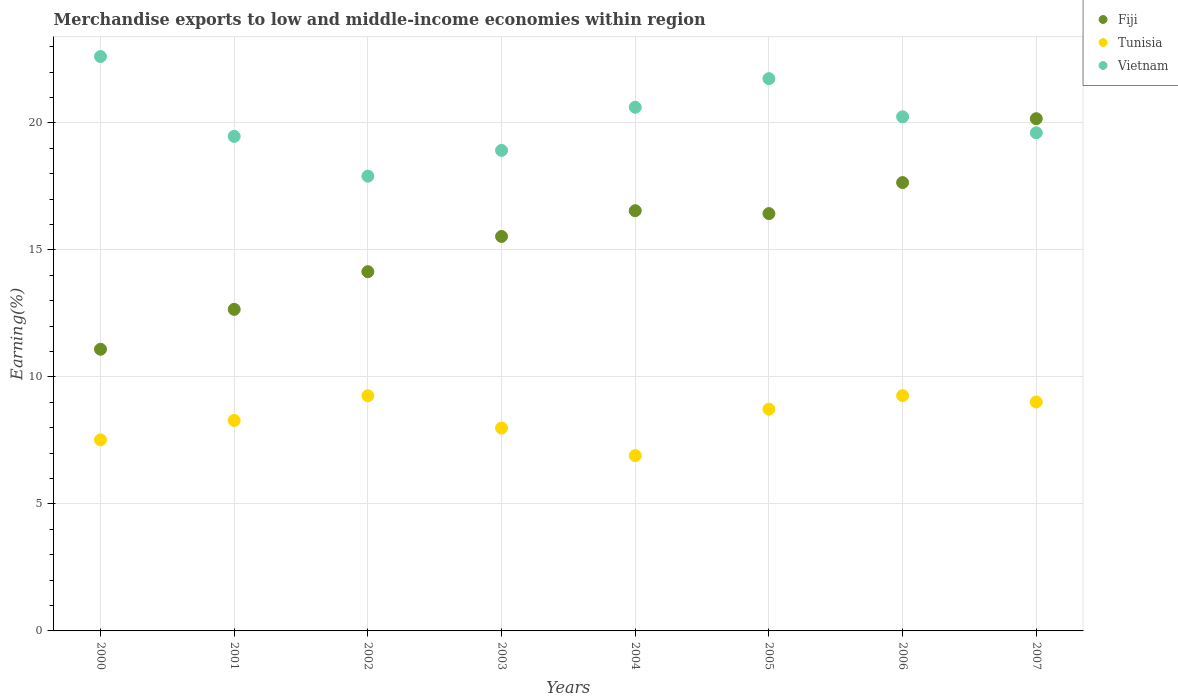Is the number of dotlines equal to the number of legend labels?
Provide a succinct answer. Yes. What is the percentage of amount earned from merchandise exports in Fiji in 2003?
Keep it short and to the point. 15.53. Across all years, what is the maximum percentage of amount earned from merchandise exports in Fiji?
Your answer should be very brief. 20.16. Across all years, what is the minimum percentage of amount earned from merchandise exports in Fiji?
Provide a short and direct response. 11.09. In which year was the percentage of amount earned from merchandise exports in Fiji maximum?
Keep it short and to the point. 2007. What is the total percentage of amount earned from merchandise exports in Fiji in the graph?
Your response must be concise. 124.2. What is the difference between the percentage of amount earned from merchandise exports in Fiji in 2001 and that in 2007?
Your answer should be compact. -7.51. What is the difference between the percentage of amount earned from merchandise exports in Tunisia in 2001 and the percentage of amount earned from merchandise exports in Fiji in 2005?
Your answer should be very brief. -8.14. What is the average percentage of amount earned from merchandise exports in Vietnam per year?
Offer a very short reply. 20.14. In the year 2006, what is the difference between the percentage of amount earned from merchandise exports in Vietnam and percentage of amount earned from merchandise exports in Fiji?
Offer a very short reply. 2.59. What is the ratio of the percentage of amount earned from merchandise exports in Tunisia in 2002 to that in 2004?
Give a very brief answer. 1.34. Is the difference between the percentage of amount earned from merchandise exports in Vietnam in 2003 and 2005 greater than the difference between the percentage of amount earned from merchandise exports in Fiji in 2003 and 2005?
Keep it short and to the point. No. What is the difference between the highest and the second highest percentage of amount earned from merchandise exports in Tunisia?
Offer a very short reply. 0.01. What is the difference between the highest and the lowest percentage of amount earned from merchandise exports in Vietnam?
Give a very brief answer. 4.71. In how many years, is the percentage of amount earned from merchandise exports in Tunisia greater than the average percentage of amount earned from merchandise exports in Tunisia taken over all years?
Ensure brevity in your answer.  4. Is the sum of the percentage of amount earned from merchandise exports in Vietnam in 2000 and 2004 greater than the maximum percentage of amount earned from merchandise exports in Fiji across all years?
Provide a short and direct response. Yes. Is it the case that in every year, the sum of the percentage of amount earned from merchandise exports in Tunisia and percentage of amount earned from merchandise exports in Fiji  is greater than the percentage of amount earned from merchandise exports in Vietnam?
Keep it short and to the point. No. Does the percentage of amount earned from merchandise exports in Fiji monotonically increase over the years?
Give a very brief answer. No. Is the percentage of amount earned from merchandise exports in Fiji strictly greater than the percentage of amount earned from merchandise exports in Tunisia over the years?
Offer a terse response. Yes. Does the graph contain grids?
Make the answer very short. Yes. Where does the legend appear in the graph?
Give a very brief answer. Top right. What is the title of the graph?
Your answer should be compact. Merchandise exports to low and middle-income economies within region. Does "El Salvador" appear as one of the legend labels in the graph?
Provide a short and direct response. No. What is the label or title of the X-axis?
Your response must be concise. Years. What is the label or title of the Y-axis?
Offer a very short reply. Earning(%). What is the Earning(%) in Fiji in 2000?
Ensure brevity in your answer.  11.09. What is the Earning(%) in Tunisia in 2000?
Your answer should be compact. 7.52. What is the Earning(%) of Vietnam in 2000?
Give a very brief answer. 22.61. What is the Earning(%) of Fiji in 2001?
Provide a succinct answer. 12.66. What is the Earning(%) in Tunisia in 2001?
Your answer should be compact. 8.28. What is the Earning(%) in Vietnam in 2001?
Ensure brevity in your answer.  19.47. What is the Earning(%) in Fiji in 2002?
Keep it short and to the point. 14.14. What is the Earning(%) of Tunisia in 2002?
Your answer should be very brief. 9.26. What is the Earning(%) of Vietnam in 2002?
Your response must be concise. 17.9. What is the Earning(%) of Fiji in 2003?
Your answer should be very brief. 15.53. What is the Earning(%) of Tunisia in 2003?
Offer a terse response. 7.98. What is the Earning(%) of Vietnam in 2003?
Offer a very short reply. 18.92. What is the Earning(%) of Fiji in 2004?
Your answer should be compact. 16.54. What is the Earning(%) of Tunisia in 2004?
Ensure brevity in your answer.  6.9. What is the Earning(%) of Vietnam in 2004?
Ensure brevity in your answer.  20.61. What is the Earning(%) of Fiji in 2005?
Your answer should be very brief. 16.43. What is the Earning(%) of Tunisia in 2005?
Provide a succinct answer. 8.73. What is the Earning(%) in Vietnam in 2005?
Provide a succinct answer. 21.74. What is the Earning(%) of Fiji in 2006?
Your response must be concise. 17.65. What is the Earning(%) in Tunisia in 2006?
Make the answer very short. 9.26. What is the Earning(%) in Vietnam in 2006?
Make the answer very short. 20.24. What is the Earning(%) of Fiji in 2007?
Offer a terse response. 20.16. What is the Earning(%) of Tunisia in 2007?
Offer a terse response. 9.01. What is the Earning(%) in Vietnam in 2007?
Offer a very short reply. 19.61. Across all years, what is the maximum Earning(%) of Fiji?
Provide a short and direct response. 20.16. Across all years, what is the maximum Earning(%) of Tunisia?
Make the answer very short. 9.26. Across all years, what is the maximum Earning(%) of Vietnam?
Provide a short and direct response. 22.61. Across all years, what is the minimum Earning(%) of Fiji?
Give a very brief answer. 11.09. Across all years, what is the minimum Earning(%) of Tunisia?
Provide a succinct answer. 6.9. Across all years, what is the minimum Earning(%) of Vietnam?
Provide a succinct answer. 17.9. What is the total Earning(%) in Fiji in the graph?
Your response must be concise. 124.2. What is the total Earning(%) of Tunisia in the graph?
Make the answer very short. 66.95. What is the total Earning(%) in Vietnam in the graph?
Offer a terse response. 161.09. What is the difference between the Earning(%) in Fiji in 2000 and that in 2001?
Provide a short and direct response. -1.57. What is the difference between the Earning(%) of Tunisia in 2000 and that in 2001?
Your answer should be compact. -0.76. What is the difference between the Earning(%) in Vietnam in 2000 and that in 2001?
Make the answer very short. 3.14. What is the difference between the Earning(%) of Fiji in 2000 and that in 2002?
Make the answer very short. -3.05. What is the difference between the Earning(%) in Tunisia in 2000 and that in 2002?
Your answer should be very brief. -1.73. What is the difference between the Earning(%) in Vietnam in 2000 and that in 2002?
Give a very brief answer. 4.71. What is the difference between the Earning(%) of Fiji in 2000 and that in 2003?
Make the answer very short. -4.44. What is the difference between the Earning(%) in Tunisia in 2000 and that in 2003?
Your response must be concise. -0.46. What is the difference between the Earning(%) of Vietnam in 2000 and that in 2003?
Ensure brevity in your answer.  3.7. What is the difference between the Earning(%) of Fiji in 2000 and that in 2004?
Your response must be concise. -5.45. What is the difference between the Earning(%) in Tunisia in 2000 and that in 2004?
Your response must be concise. 0.62. What is the difference between the Earning(%) of Vietnam in 2000 and that in 2004?
Your answer should be compact. 2. What is the difference between the Earning(%) in Fiji in 2000 and that in 2005?
Offer a very short reply. -5.34. What is the difference between the Earning(%) of Tunisia in 2000 and that in 2005?
Keep it short and to the point. -1.21. What is the difference between the Earning(%) in Vietnam in 2000 and that in 2005?
Your answer should be compact. 0.87. What is the difference between the Earning(%) of Fiji in 2000 and that in 2006?
Provide a succinct answer. -6.56. What is the difference between the Earning(%) in Tunisia in 2000 and that in 2006?
Give a very brief answer. -1.74. What is the difference between the Earning(%) of Vietnam in 2000 and that in 2006?
Keep it short and to the point. 2.37. What is the difference between the Earning(%) in Fiji in 2000 and that in 2007?
Your answer should be compact. -9.08. What is the difference between the Earning(%) in Tunisia in 2000 and that in 2007?
Make the answer very short. -1.49. What is the difference between the Earning(%) in Vietnam in 2000 and that in 2007?
Ensure brevity in your answer.  3. What is the difference between the Earning(%) in Fiji in 2001 and that in 2002?
Provide a short and direct response. -1.48. What is the difference between the Earning(%) of Tunisia in 2001 and that in 2002?
Provide a short and direct response. -0.97. What is the difference between the Earning(%) of Vietnam in 2001 and that in 2002?
Your answer should be very brief. 1.57. What is the difference between the Earning(%) in Fiji in 2001 and that in 2003?
Keep it short and to the point. -2.87. What is the difference between the Earning(%) in Tunisia in 2001 and that in 2003?
Your response must be concise. 0.3. What is the difference between the Earning(%) of Vietnam in 2001 and that in 2003?
Provide a short and direct response. 0.55. What is the difference between the Earning(%) of Fiji in 2001 and that in 2004?
Your response must be concise. -3.88. What is the difference between the Earning(%) of Tunisia in 2001 and that in 2004?
Offer a very short reply. 1.38. What is the difference between the Earning(%) in Vietnam in 2001 and that in 2004?
Give a very brief answer. -1.15. What is the difference between the Earning(%) of Fiji in 2001 and that in 2005?
Your answer should be compact. -3.77. What is the difference between the Earning(%) in Tunisia in 2001 and that in 2005?
Your answer should be compact. -0.44. What is the difference between the Earning(%) of Vietnam in 2001 and that in 2005?
Give a very brief answer. -2.27. What is the difference between the Earning(%) of Fiji in 2001 and that in 2006?
Give a very brief answer. -4.99. What is the difference between the Earning(%) in Tunisia in 2001 and that in 2006?
Provide a short and direct response. -0.98. What is the difference between the Earning(%) of Vietnam in 2001 and that in 2006?
Your response must be concise. -0.77. What is the difference between the Earning(%) in Fiji in 2001 and that in 2007?
Keep it short and to the point. -7.51. What is the difference between the Earning(%) in Tunisia in 2001 and that in 2007?
Provide a short and direct response. -0.73. What is the difference between the Earning(%) in Vietnam in 2001 and that in 2007?
Offer a very short reply. -0.14. What is the difference between the Earning(%) in Fiji in 2002 and that in 2003?
Ensure brevity in your answer.  -1.39. What is the difference between the Earning(%) in Tunisia in 2002 and that in 2003?
Your answer should be very brief. 1.27. What is the difference between the Earning(%) of Vietnam in 2002 and that in 2003?
Your answer should be compact. -1.01. What is the difference between the Earning(%) in Fiji in 2002 and that in 2004?
Offer a very short reply. -2.4. What is the difference between the Earning(%) in Tunisia in 2002 and that in 2004?
Offer a very short reply. 2.36. What is the difference between the Earning(%) in Vietnam in 2002 and that in 2004?
Offer a very short reply. -2.71. What is the difference between the Earning(%) in Fiji in 2002 and that in 2005?
Offer a very short reply. -2.29. What is the difference between the Earning(%) of Tunisia in 2002 and that in 2005?
Give a very brief answer. 0.53. What is the difference between the Earning(%) of Vietnam in 2002 and that in 2005?
Offer a very short reply. -3.84. What is the difference between the Earning(%) of Fiji in 2002 and that in 2006?
Provide a short and direct response. -3.51. What is the difference between the Earning(%) in Tunisia in 2002 and that in 2006?
Keep it short and to the point. -0.01. What is the difference between the Earning(%) in Vietnam in 2002 and that in 2006?
Your answer should be compact. -2.33. What is the difference between the Earning(%) of Fiji in 2002 and that in 2007?
Provide a short and direct response. -6.02. What is the difference between the Earning(%) in Tunisia in 2002 and that in 2007?
Ensure brevity in your answer.  0.24. What is the difference between the Earning(%) in Vietnam in 2002 and that in 2007?
Your answer should be very brief. -1.71. What is the difference between the Earning(%) in Fiji in 2003 and that in 2004?
Your answer should be very brief. -1.01. What is the difference between the Earning(%) in Tunisia in 2003 and that in 2004?
Offer a very short reply. 1.08. What is the difference between the Earning(%) in Vietnam in 2003 and that in 2004?
Make the answer very short. -1.7. What is the difference between the Earning(%) of Fiji in 2003 and that in 2005?
Provide a succinct answer. -0.9. What is the difference between the Earning(%) of Tunisia in 2003 and that in 2005?
Provide a succinct answer. -0.74. What is the difference between the Earning(%) in Vietnam in 2003 and that in 2005?
Provide a short and direct response. -2.82. What is the difference between the Earning(%) of Fiji in 2003 and that in 2006?
Your answer should be very brief. -2.12. What is the difference between the Earning(%) of Tunisia in 2003 and that in 2006?
Provide a succinct answer. -1.28. What is the difference between the Earning(%) in Vietnam in 2003 and that in 2006?
Keep it short and to the point. -1.32. What is the difference between the Earning(%) of Fiji in 2003 and that in 2007?
Ensure brevity in your answer.  -4.64. What is the difference between the Earning(%) of Tunisia in 2003 and that in 2007?
Offer a terse response. -1.03. What is the difference between the Earning(%) in Vietnam in 2003 and that in 2007?
Make the answer very short. -0.69. What is the difference between the Earning(%) of Fiji in 2004 and that in 2005?
Make the answer very short. 0.11. What is the difference between the Earning(%) in Tunisia in 2004 and that in 2005?
Make the answer very short. -1.83. What is the difference between the Earning(%) of Vietnam in 2004 and that in 2005?
Offer a very short reply. -1.13. What is the difference between the Earning(%) of Fiji in 2004 and that in 2006?
Your answer should be very brief. -1.11. What is the difference between the Earning(%) of Tunisia in 2004 and that in 2006?
Provide a succinct answer. -2.36. What is the difference between the Earning(%) of Vietnam in 2004 and that in 2006?
Keep it short and to the point. 0.38. What is the difference between the Earning(%) in Fiji in 2004 and that in 2007?
Your response must be concise. -3.62. What is the difference between the Earning(%) of Tunisia in 2004 and that in 2007?
Your answer should be very brief. -2.11. What is the difference between the Earning(%) of Fiji in 2005 and that in 2006?
Make the answer very short. -1.22. What is the difference between the Earning(%) in Tunisia in 2005 and that in 2006?
Your answer should be very brief. -0.54. What is the difference between the Earning(%) in Vietnam in 2005 and that in 2006?
Offer a terse response. 1.5. What is the difference between the Earning(%) of Fiji in 2005 and that in 2007?
Make the answer very short. -3.74. What is the difference between the Earning(%) of Tunisia in 2005 and that in 2007?
Ensure brevity in your answer.  -0.29. What is the difference between the Earning(%) in Vietnam in 2005 and that in 2007?
Give a very brief answer. 2.13. What is the difference between the Earning(%) in Fiji in 2006 and that in 2007?
Make the answer very short. -2.52. What is the difference between the Earning(%) of Tunisia in 2006 and that in 2007?
Your answer should be very brief. 0.25. What is the difference between the Earning(%) in Vietnam in 2006 and that in 2007?
Your answer should be compact. 0.63. What is the difference between the Earning(%) of Fiji in 2000 and the Earning(%) of Tunisia in 2001?
Your answer should be very brief. 2.8. What is the difference between the Earning(%) in Fiji in 2000 and the Earning(%) in Vietnam in 2001?
Ensure brevity in your answer.  -8.38. What is the difference between the Earning(%) of Tunisia in 2000 and the Earning(%) of Vietnam in 2001?
Your answer should be compact. -11.95. What is the difference between the Earning(%) in Fiji in 2000 and the Earning(%) in Tunisia in 2002?
Offer a terse response. 1.83. What is the difference between the Earning(%) in Fiji in 2000 and the Earning(%) in Vietnam in 2002?
Provide a succinct answer. -6.81. What is the difference between the Earning(%) of Tunisia in 2000 and the Earning(%) of Vietnam in 2002?
Your answer should be very brief. -10.38. What is the difference between the Earning(%) in Fiji in 2000 and the Earning(%) in Tunisia in 2003?
Provide a succinct answer. 3.1. What is the difference between the Earning(%) in Fiji in 2000 and the Earning(%) in Vietnam in 2003?
Give a very brief answer. -7.83. What is the difference between the Earning(%) of Tunisia in 2000 and the Earning(%) of Vietnam in 2003?
Give a very brief answer. -11.39. What is the difference between the Earning(%) in Fiji in 2000 and the Earning(%) in Tunisia in 2004?
Ensure brevity in your answer.  4.19. What is the difference between the Earning(%) in Fiji in 2000 and the Earning(%) in Vietnam in 2004?
Ensure brevity in your answer.  -9.53. What is the difference between the Earning(%) in Tunisia in 2000 and the Earning(%) in Vietnam in 2004?
Your response must be concise. -13.09. What is the difference between the Earning(%) of Fiji in 2000 and the Earning(%) of Tunisia in 2005?
Your response must be concise. 2.36. What is the difference between the Earning(%) of Fiji in 2000 and the Earning(%) of Vietnam in 2005?
Provide a short and direct response. -10.65. What is the difference between the Earning(%) of Tunisia in 2000 and the Earning(%) of Vietnam in 2005?
Provide a short and direct response. -14.22. What is the difference between the Earning(%) of Fiji in 2000 and the Earning(%) of Tunisia in 2006?
Ensure brevity in your answer.  1.82. What is the difference between the Earning(%) of Fiji in 2000 and the Earning(%) of Vietnam in 2006?
Your answer should be very brief. -9.15. What is the difference between the Earning(%) in Tunisia in 2000 and the Earning(%) in Vietnam in 2006?
Your answer should be compact. -12.72. What is the difference between the Earning(%) of Fiji in 2000 and the Earning(%) of Tunisia in 2007?
Ensure brevity in your answer.  2.07. What is the difference between the Earning(%) of Fiji in 2000 and the Earning(%) of Vietnam in 2007?
Your response must be concise. -8.52. What is the difference between the Earning(%) in Tunisia in 2000 and the Earning(%) in Vietnam in 2007?
Your answer should be compact. -12.09. What is the difference between the Earning(%) of Fiji in 2001 and the Earning(%) of Tunisia in 2002?
Offer a terse response. 3.4. What is the difference between the Earning(%) in Fiji in 2001 and the Earning(%) in Vietnam in 2002?
Offer a very short reply. -5.24. What is the difference between the Earning(%) in Tunisia in 2001 and the Earning(%) in Vietnam in 2002?
Offer a terse response. -9.62. What is the difference between the Earning(%) of Fiji in 2001 and the Earning(%) of Tunisia in 2003?
Offer a very short reply. 4.67. What is the difference between the Earning(%) of Fiji in 2001 and the Earning(%) of Vietnam in 2003?
Offer a very short reply. -6.26. What is the difference between the Earning(%) in Tunisia in 2001 and the Earning(%) in Vietnam in 2003?
Make the answer very short. -10.63. What is the difference between the Earning(%) of Fiji in 2001 and the Earning(%) of Tunisia in 2004?
Give a very brief answer. 5.76. What is the difference between the Earning(%) in Fiji in 2001 and the Earning(%) in Vietnam in 2004?
Give a very brief answer. -7.96. What is the difference between the Earning(%) in Tunisia in 2001 and the Earning(%) in Vietnam in 2004?
Give a very brief answer. -12.33. What is the difference between the Earning(%) of Fiji in 2001 and the Earning(%) of Tunisia in 2005?
Make the answer very short. 3.93. What is the difference between the Earning(%) of Fiji in 2001 and the Earning(%) of Vietnam in 2005?
Your response must be concise. -9.08. What is the difference between the Earning(%) of Tunisia in 2001 and the Earning(%) of Vietnam in 2005?
Make the answer very short. -13.46. What is the difference between the Earning(%) of Fiji in 2001 and the Earning(%) of Tunisia in 2006?
Make the answer very short. 3.39. What is the difference between the Earning(%) of Fiji in 2001 and the Earning(%) of Vietnam in 2006?
Provide a short and direct response. -7.58. What is the difference between the Earning(%) of Tunisia in 2001 and the Earning(%) of Vietnam in 2006?
Keep it short and to the point. -11.95. What is the difference between the Earning(%) of Fiji in 2001 and the Earning(%) of Tunisia in 2007?
Your answer should be very brief. 3.65. What is the difference between the Earning(%) in Fiji in 2001 and the Earning(%) in Vietnam in 2007?
Provide a short and direct response. -6.95. What is the difference between the Earning(%) in Tunisia in 2001 and the Earning(%) in Vietnam in 2007?
Give a very brief answer. -11.32. What is the difference between the Earning(%) of Fiji in 2002 and the Earning(%) of Tunisia in 2003?
Offer a terse response. 6.16. What is the difference between the Earning(%) in Fiji in 2002 and the Earning(%) in Vietnam in 2003?
Make the answer very short. -4.77. What is the difference between the Earning(%) in Tunisia in 2002 and the Earning(%) in Vietnam in 2003?
Keep it short and to the point. -9.66. What is the difference between the Earning(%) of Fiji in 2002 and the Earning(%) of Tunisia in 2004?
Your answer should be compact. 7.24. What is the difference between the Earning(%) of Fiji in 2002 and the Earning(%) of Vietnam in 2004?
Ensure brevity in your answer.  -6.47. What is the difference between the Earning(%) of Tunisia in 2002 and the Earning(%) of Vietnam in 2004?
Your response must be concise. -11.36. What is the difference between the Earning(%) in Fiji in 2002 and the Earning(%) in Tunisia in 2005?
Your answer should be very brief. 5.41. What is the difference between the Earning(%) in Fiji in 2002 and the Earning(%) in Vietnam in 2005?
Provide a succinct answer. -7.6. What is the difference between the Earning(%) in Tunisia in 2002 and the Earning(%) in Vietnam in 2005?
Your response must be concise. -12.48. What is the difference between the Earning(%) of Fiji in 2002 and the Earning(%) of Tunisia in 2006?
Provide a succinct answer. 4.88. What is the difference between the Earning(%) in Fiji in 2002 and the Earning(%) in Vietnam in 2006?
Your response must be concise. -6.1. What is the difference between the Earning(%) in Tunisia in 2002 and the Earning(%) in Vietnam in 2006?
Your response must be concise. -10.98. What is the difference between the Earning(%) of Fiji in 2002 and the Earning(%) of Tunisia in 2007?
Your answer should be compact. 5.13. What is the difference between the Earning(%) in Fiji in 2002 and the Earning(%) in Vietnam in 2007?
Provide a succinct answer. -5.47. What is the difference between the Earning(%) of Tunisia in 2002 and the Earning(%) of Vietnam in 2007?
Ensure brevity in your answer.  -10.35. What is the difference between the Earning(%) of Fiji in 2003 and the Earning(%) of Tunisia in 2004?
Your answer should be compact. 8.63. What is the difference between the Earning(%) of Fiji in 2003 and the Earning(%) of Vietnam in 2004?
Give a very brief answer. -5.09. What is the difference between the Earning(%) in Tunisia in 2003 and the Earning(%) in Vietnam in 2004?
Give a very brief answer. -12.63. What is the difference between the Earning(%) in Fiji in 2003 and the Earning(%) in Tunisia in 2005?
Provide a short and direct response. 6.8. What is the difference between the Earning(%) in Fiji in 2003 and the Earning(%) in Vietnam in 2005?
Your response must be concise. -6.21. What is the difference between the Earning(%) in Tunisia in 2003 and the Earning(%) in Vietnam in 2005?
Offer a very short reply. -13.76. What is the difference between the Earning(%) in Fiji in 2003 and the Earning(%) in Tunisia in 2006?
Your answer should be very brief. 6.26. What is the difference between the Earning(%) of Fiji in 2003 and the Earning(%) of Vietnam in 2006?
Ensure brevity in your answer.  -4.71. What is the difference between the Earning(%) in Tunisia in 2003 and the Earning(%) in Vietnam in 2006?
Offer a very short reply. -12.25. What is the difference between the Earning(%) in Fiji in 2003 and the Earning(%) in Tunisia in 2007?
Your answer should be very brief. 6.52. What is the difference between the Earning(%) of Fiji in 2003 and the Earning(%) of Vietnam in 2007?
Ensure brevity in your answer.  -4.08. What is the difference between the Earning(%) of Tunisia in 2003 and the Earning(%) of Vietnam in 2007?
Offer a very short reply. -11.62. What is the difference between the Earning(%) of Fiji in 2004 and the Earning(%) of Tunisia in 2005?
Give a very brief answer. 7.81. What is the difference between the Earning(%) of Fiji in 2004 and the Earning(%) of Vietnam in 2005?
Ensure brevity in your answer.  -5.2. What is the difference between the Earning(%) in Tunisia in 2004 and the Earning(%) in Vietnam in 2005?
Give a very brief answer. -14.84. What is the difference between the Earning(%) in Fiji in 2004 and the Earning(%) in Tunisia in 2006?
Offer a very short reply. 7.28. What is the difference between the Earning(%) of Fiji in 2004 and the Earning(%) of Vietnam in 2006?
Offer a very short reply. -3.7. What is the difference between the Earning(%) of Tunisia in 2004 and the Earning(%) of Vietnam in 2006?
Offer a very short reply. -13.34. What is the difference between the Earning(%) in Fiji in 2004 and the Earning(%) in Tunisia in 2007?
Provide a short and direct response. 7.53. What is the difference between the Earning(%) in Fiji in 2004 and the Earning(%) in Vietnam in 2007?
Keep it short and to the point. -3.07. What is the difference between the Earning(%) in Tunisia in 2004 and the Earning(%) in Vietnam in 2007?
Provide a succinct answer. -12.71. What is the difference between the Earning(%) of Fiji in 2005 and the Earning(%) of Tunisia in 2006?
Your answer should be very brief. 7.16. What is the difference between the Earning(%) in Fiji in 2005 and the Earning(%) in Vietnam in 2006?
Offer a terse response. -3.81. What is the difference between the Earning(%) in Tunisia in 2005 and the Earning(%) in Vietnam in 2006?
Provide a short and direct response. -11.51. What is the difference between the Earning(%) of Fiji in 2005 and the Earning(%) of Tunisia in 2007?
Ensure brevity in your answer.  7.42. What is the difference between the Earning(%) of Fiji in 2005 and the Earning(%) of Vietnam in 2007?
Offer a terse response. -3.18. What is the difference between the Earning(%) in Tunisia in 2005 and the Earning(%) in Vietnam in 2007?
Keep it short and to the point. -10.88. What is the difference between the Earning(%) in Fiji in 2006 and the Earning(%) in Tunisia in 2007?
Your answer should be very brief. 8.64. What is the difference between the Earning(%) of Fiji in 2006 and the Earning(%) of Vietnam in 2007?
Your answer should be very brief. -1.96. What is the difference between the Earning(%) of Tunisia in 2006 and the Earning(%) of Vietnam in 2007?
Keep it short and to the point. -10.34. What is the average Earning(%) in Fiji per year?
Make the answer very short. 15.52. What is the average Earning(%) in Tunisia per year?
Provide a short and direct response. 8.37. What is the average Earning(%) of Vietnam per year?
Offer a very short reply. 20.14. In the year 2000, what is the difference between the Earning(%) in Fiji and Earning(%) in Tunisia?
Offer a terse response. 3.57. In the year 2000, what is the difference between the Earning(%) of Fiji and Earning(%) of Vietnam?
Your answer should be compact. -11.52. In the year 2000, what is the difference between the Earning(%) in Tunisia and Earning(%) in Vietnam?
Provide a short and direct response. -15.09. In the year 2001, what is the difference between the Earning(%) of Fiji and Earning(%) of Tunisia?
Give a very brief answer. 4.37. In the year 2001, what is the difference between the Earning(%) of Fiji and Earning(%) of Vietnam?
Give a very brief answer. -6.81. In the year 2001, what is the difference between the Earning(%) in Tunisia and Earning(%) in Vietnam?
Your response must be concise. -11.18. In the year 2002, what is the difference between the Earning(%) in Fiji and Earning(%) in Tunisia?
Give a very brief answer. 4.88. In the year 2002, what is the difference between the Earning(%) of Fiji and Earning(%) of Vietnam?
Keep it short and to the point. -3.76. In the year 2002, what is the difference between the Earning(%) in Tunisia and Earning(%) in Vietnam?
Offer a very short reply. -8.65. In the year 2003, what is the difference between the Earning(%) of Fiji and Earning(%) of Tunisia?
Make the answer very short. 7.54. In the year 2003, what is the difference between the Earning(%) of Fiji and Earning(%) of Vietnam?
Give a very brief answer. -3.39. In the year 2003, what is the difference between the Earning(%) of Tunisia and Earning(%) of Vietnam?
Give a very brief answer. -10.93. In the year 2004, what is the difference between the Earning(%) of Fiji and Earning(%) of Tunisia?
Provide a short and direct response. 9.64. In the year 2004, what is the difference between the Earning(%) of Fiji and Earning(%) of Vietnam?
Your response must be concise. -4.07. In the year 2004, what is the difference between the Earning(%) of Tunisia and Earning(%) of Vietnam?
Provide a succinct answer. -13.71. In the year 2005, what is the difference between the Earning(%) in Fiji and Earning(%) in Tunisia?
Offer a terse response. 7.7. In the year 2005, what is the difference between the Earning(%) of Fiji and Earning(%) of Vietnam?
Make the answer very short. -5.31. In the year 2005, what is the difference between the Earning(%) in Tunisia and Earning(%) in Vietnam?
Your response must be concise. -13.01. In the year 2006, what is the difference between the Earning(%) of Fiji and Earning(%) of Tunisia?
Offer a very short reply. 8.38. In the year 2006, what is the difference between the Earning(%) in Fiji and Earning(%) in Vietnam?
Keep it short and to the point. -2.59. In the year 2006, what is the difference between the Earning(%) in Tunisia and Earning(%) in Vietnam?
Provide a short and direct response. -10.97. In the year 2007, what is the difference between the Earning(%) of Fiji and Earning(%) of Tunisia?
Offer a very short reply. 11.15. In the year 2007, what is the difference between the Earning(%) of Fiji and Earning(%) of Vietnam?
Your response must be concise. 0.56. In the year 2007, what is the difference between the Earning(%) of Tunisia and Earning(%) of Vietnam?
Make the answer very short. -10.6. What is the ratio of the Earning(%) of Fiji in 2000 to that in 2001?
Your answer should be compact. 0.88. What is the ratio of the Earning(%) in Tunisia in 2000 to that in 2001?
Offer a terse response. 0.91. What is the ratio of the Earning(%) of Vietnam in 2000 to that in 2001?
Offer a terse response. 1.16. What is the ratio of the Earning(%) in Fiji in 2000 to that in 2002?
Offer a very short reply. 0.78. What is the ratio of the Earning(%) in Tunisia in 2000 to that in 2002?
Offer a terse response. 0.81. What is the ratio of the Earning(%) of Vietnam in 2000 to that in 2002?
Provide a succinct answer. 1.26. What is the ratio of the Earning(%) of Fiji in 2000 to that in 2003?
Make the answer very short. 0.71. What is the ratio of the Earning(%) in Tunisia in 2000 to that in 2003?
Offer a very short reply. 0.94. What is the ratio of the Earning(%) of Vietnam in 2000 to that in 2003?
Ensure brevity in your answer.  1.2. What is the ratio of the Earning(%) in Fiji in 2000 to that in 2004?
Your response must be concise. 0.67. What is the ratio of the Earning(%) of Tunisia in 2000 to that in 2004?
Provide a short and direct response. 1.09. What is the ratio of the Earning(%) of Vietnam in 2000 to that in 2004?
Keep it short and to the point. 1.1. What is the ratio of the Earning(%) of Fiji in 2000 to that in 2005?
Offer a terse response. 0.67. What is the ratio of the Earning(%) in Tunisia in 2000 to that in 2005?
Your response must be concise. 0.86. What is the ratio of the Earning(%) of Fiji in 2000 to that in 2006?
Provide a short and direct response. 0.63. What is the ratio of the Earning(%) in Tunisia in 2000 to that in 2006?
Your answer should be compact. 0.81. What is the ratio of the Earning(%) of Vietnam in 2000 to that in 2006?
Give a very brief answer. 1.12. What is the ratio of the Earning(%) of Fiji in 2000 to that in 2007?
Your response must be concise. 0.55. What is the ratio of the Earning(%) in Tunisia in 2000 to that in 2007?
Your answer should be compact. 0.83. What is the ratio of the Earning(%) of Vietnam in 2000 to that in 2007?
Your answer should be compact. 1.15. What is the ratio of the Earning(%) of Fiji in 2001 to that in 2002?
Your response must be concise. 0.9. What is the ratio of the Earning(%) of Tunisia in 2001 to that in 2002?
Offer a terse response. 0.9. What is the ratio of the Earning(%) in Vietnam in 2001 to that in 2002?
Give a very brief answer. 1.09. What is the ratio of the Earning(%) in Fiji in 2001 to that in 2003?
Make the answer very short. 0.82. What is the ratio of the Earning(%) of Tunisia in 2001 to that in 2003?
Provide a succinct answer. 1.04. What is the ratio of the Earning(%) of Vietnam in 2001 to that in 2003?
Give a very brief answer. 1.03. What is the ratio of the Earning(%) in Fiji in 2001 to that in 2004?
Provide a succinct answer. 0.77. What is the ratio of the Earning(%) of Tunisia in 2001 to that in 2004?
Provide a succinct answer. 1.2. What is the ratio of the Earning(%) of Fiji in 2001 to that in 2005?
Ensure brevity in your answer.  0.77. What is the ratio of the Earning(%) of Tunisia in 2001 to that in 2005?
Provide a short and direct response. 0.95. What is the ratio of the Earning(%) of Vietnam in 2001 to that in 2005?
Your answer should be very brief. 0.9. What is the ratio of the Earning(%) in Fiji in 2001 to that in 2006?
Your response must be concise. 0.72. What is the ratio of the Earning(%) in Tunisia in 2001 to that in 2006?
Make the answer very short. 0.89. What is the ratio of the Earning(%) in Vietnam in 2001 to that in 2006?
Provide a short and direct response. 0.96. What is the ratio of the Earning(%) of Fiji in 2001 to that in 2007?
Provide a short and direct response. 0.63. What is the ratio of the Earning(%) of Tunisia in 2001 to that in 2007?
Keep it short and to the point. 0.92. What is the ratio of the Earning(%) in Vietnam in 2001 to that in 2007?
Offer a terse response. 0.99. What is the ratio of the Earning(%) in Fiji in 2002 to that in 2003?
Provide a short and direct response. 0.91. What is the ratio of the Earning(%) in Tunisia in 2002 to that in 2003?
Give a very brief answer. 1.16. What is the ratio of the Earning(%) in Vietnam in 2002 to that in 2003?
Provide a short and direct response. 0.95. What is the ratio of the Earning(%) in Fiji in 2002 to that in 2004?
Make the answer very short. 0.85. What is the ratio of the Earning(%) of Tunisia in 2002 to that in 2004?
Your response must be concise. 1.34. What is the ratio of the Earning(%) of Vietnam in 2002 to that in 2004?
Keep it short and to the point. 0.87. What is the ratio of the Earning(%) of Fiji in 2002 to that in 2005?
Your answer should be very brief. 0.86. What is the ratio of the Earning(%) in Tunisia in 2002 to that in 2005?
Offer a terse response. 1.06. What is the ratio of the Earning(%) in Vietnam in 2002 to that in 2005?
Keep it short and to the point. 0.82. What is the ratio of the Earning(%) of Fiji in 2002 to that in 2006?
Make the answer very short. 0.8. What is the ratio of the Earning(%) in Tunisia in 2002 to that in 2006?
Make the answer very short. 1. What is the ratio of the Earning(%) in Vietnam in 2002 to that in 2006?
Offer a very short reply. 0.88. What is the ratio of the Earning(%) of Fiji in 2002 to that in 2007?
Offer a very short reply. 0.7. What is the ratio of the Earning(%) in Tunisia in 2002 to that in 2007?
Keep it short and to the point. 1.03. What is the ratio of the Earning(%) of Fiji in 2003 to that in 2004?
Make the answer very short. 0.94. What is the ratio of the Earning(%) of Tunisia in 2003 to that in 2004?
Your answer should be very brief. 1.16. What is the ratio of the Earning(%) in Vietnam in 2003 to that in 2004?
Make the answer very short. 0.92. What is the ratio of the Earning(%) in Fiji in 2003 to that in 2005?
Give a very brief answer. 0.95. What is the ratio of the Earning(%) of Tunisia in 2003 to that in 2005?
Offer a terse response. 0.91. What is the ratio of the Earning(%) of Vietnam in 2003 to that in 2005?
Provide a succinct answer. 0.87. What is the ratio of the Earning(%) of Fiji in 2003 to that in 2006?
Your answer should be compact. 0.88. What is the ratio of the Earning(%) in Tunisia in 2003 to that in 2006?
Offer a terse response. 0.86. What is the ratio of the Earning(%) of Vietnam in 2003 to that in 2006?
Keep it short and to the point. 0.93. What is the ratio of the Earning(%) of Fiji in 2003 to that in 2007?
Make the answer very short. 0.77. What is the ratio of the Earning(%) of Tunisia in 2003 to that in 2007?
Keep it short and to the point. 0.89. What is the ratio of the Earning(%) of Vietnam in 2003 to that in 2007?
Ensure brevity in your answer.  0.96. What is the ratio of the Earning(%) in Tunisia in 2004 to that in 2005?
Provide a short and direct response. 0.79. What is the ratio of the Earning(%) in Vietnam in 2004 to that in 2005?
Provide a short and direct response. 0.95. What is the ratio of the Earning(%) in Fiji in 2004 to that in 2006?
Ensure brevity in your answer.  0.94. What is the ratio of the Earning(%) in Tunisia in 2004 to that in 2006?
Make the answer very short. 0.74. What is the ratio of the Earning(%) of Vietnam in 2004 to that in 2006?
Ensure brevity in your answer.  1.02. What is the ratio of the Earning(%) of Fiji in 2004 to that in 2007?
Make the answer very short. 0.82. What is the ratio of the Earning(%) of Tunisia in 2004 to that in 2007?
Make the answer very short. 0.77. What is the ratio of the Earning(%) in Vietnam in 2004 to that in 2007?
Provide a short and direct response. 1.05. What is the ratio of the Earning(%) of Fiji in 2005 to that in 2006?
Ensure brevity in your answer.  0.93. What is the ratio of the Earning(%) of Tunisia in 2005 to that in 2006?
Provide a succinct answer. 0.94. What is the ratio of the Earning(%) of Vietnam in 2005 to that in 2006?
Provide a succinct answer. 1.07. What is the ratio of the Earning(%) in Fiji in 2005 to that in 2007?
Give a very brief answer. 0.81. What is the ratio of the Earning(%) in Tunisia in 2005 to that in 2007?
Ensure brevity in your answer.  0.97. What is the ratio of the Earning(%) in Vietnam in 2005 to that in 2007?
Your answer should be compact. 1.11. What is the ratio of the Earning(%) in Fiji in 2006 to that in 2007?
Offer a very short reply. 0.88. What is the ratio of the Earning(%) in Tunisia in 2006 to that in 2007?
Keep it short and to the point. 1.03. What is the ratio of the Earning(%) in Vietnam in 2006 to that in 2007?
Give a very brief answer. 1.03. What is the difference between the highest and the second highest Earning(%) of Fiji?
Keep it short and to the point. 2.52. What is the difference between the highest and the second highest Earning(%) in Tunisia?
Your answer should be very brief. 0.01. What is the difference between the highest and the second highest Earning(%) of Vietnam?
Provide a succinct answer. 0.87. What is the difference between the highest and the lowest Earning(%) in Fiji?
Provide a short and direct response. 9.08. What is the difference between the highest and the lowest Earning(%) of Tunisia?
Your answer should be very brief. 2.36. What is the difference between the highest and the lowest Earning(%) in Vietnam?
Ensure brevity in your answer.  4.71. 